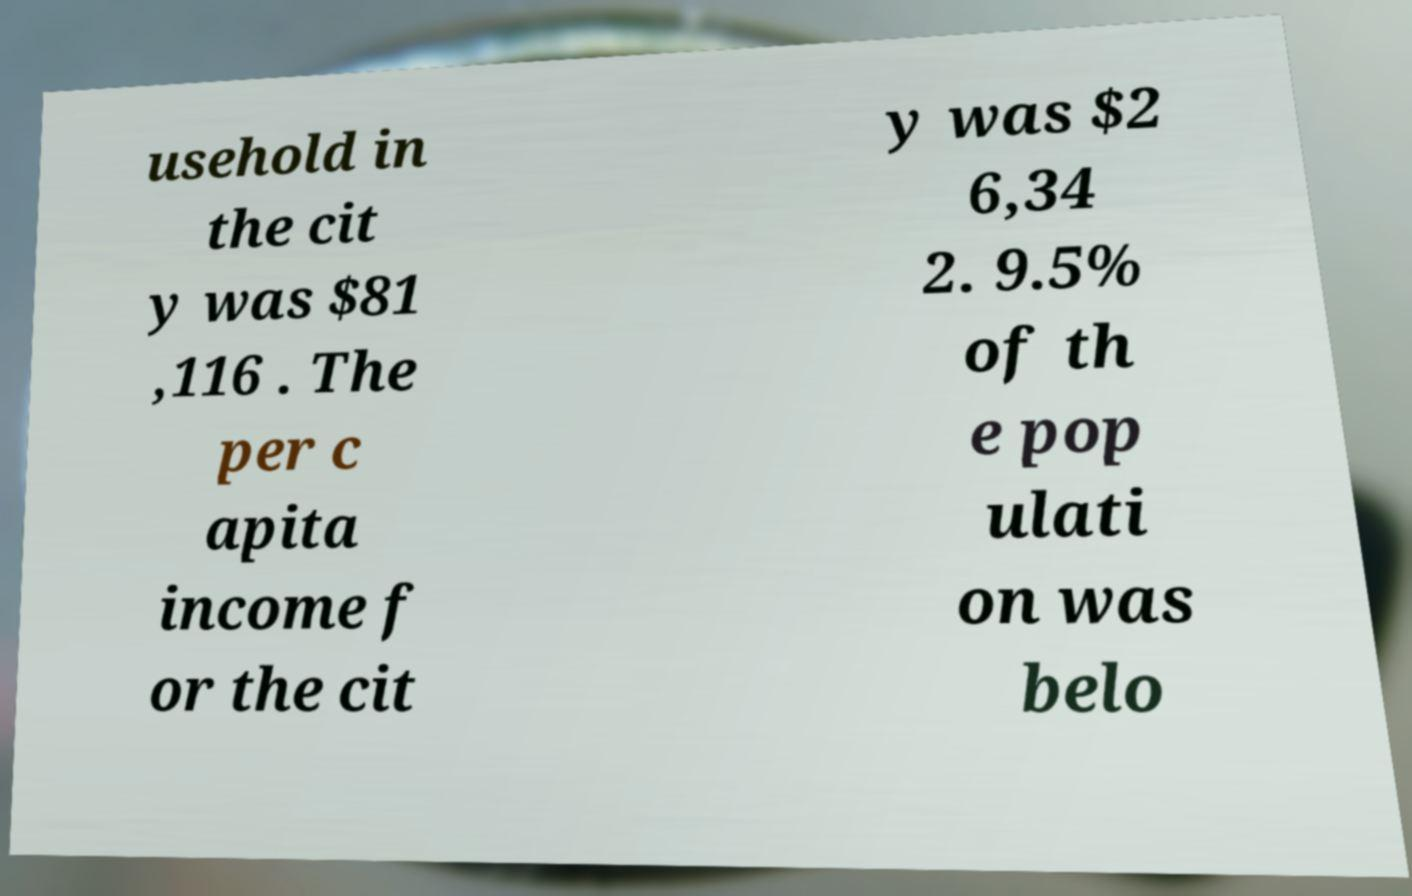Please identify and transcribe the text found in this image. usehold in the cit y was $81 ,116 . The per c apita income f or the cit y was $2 6,34 2. 9.5% of th e pop ulati on was belo 